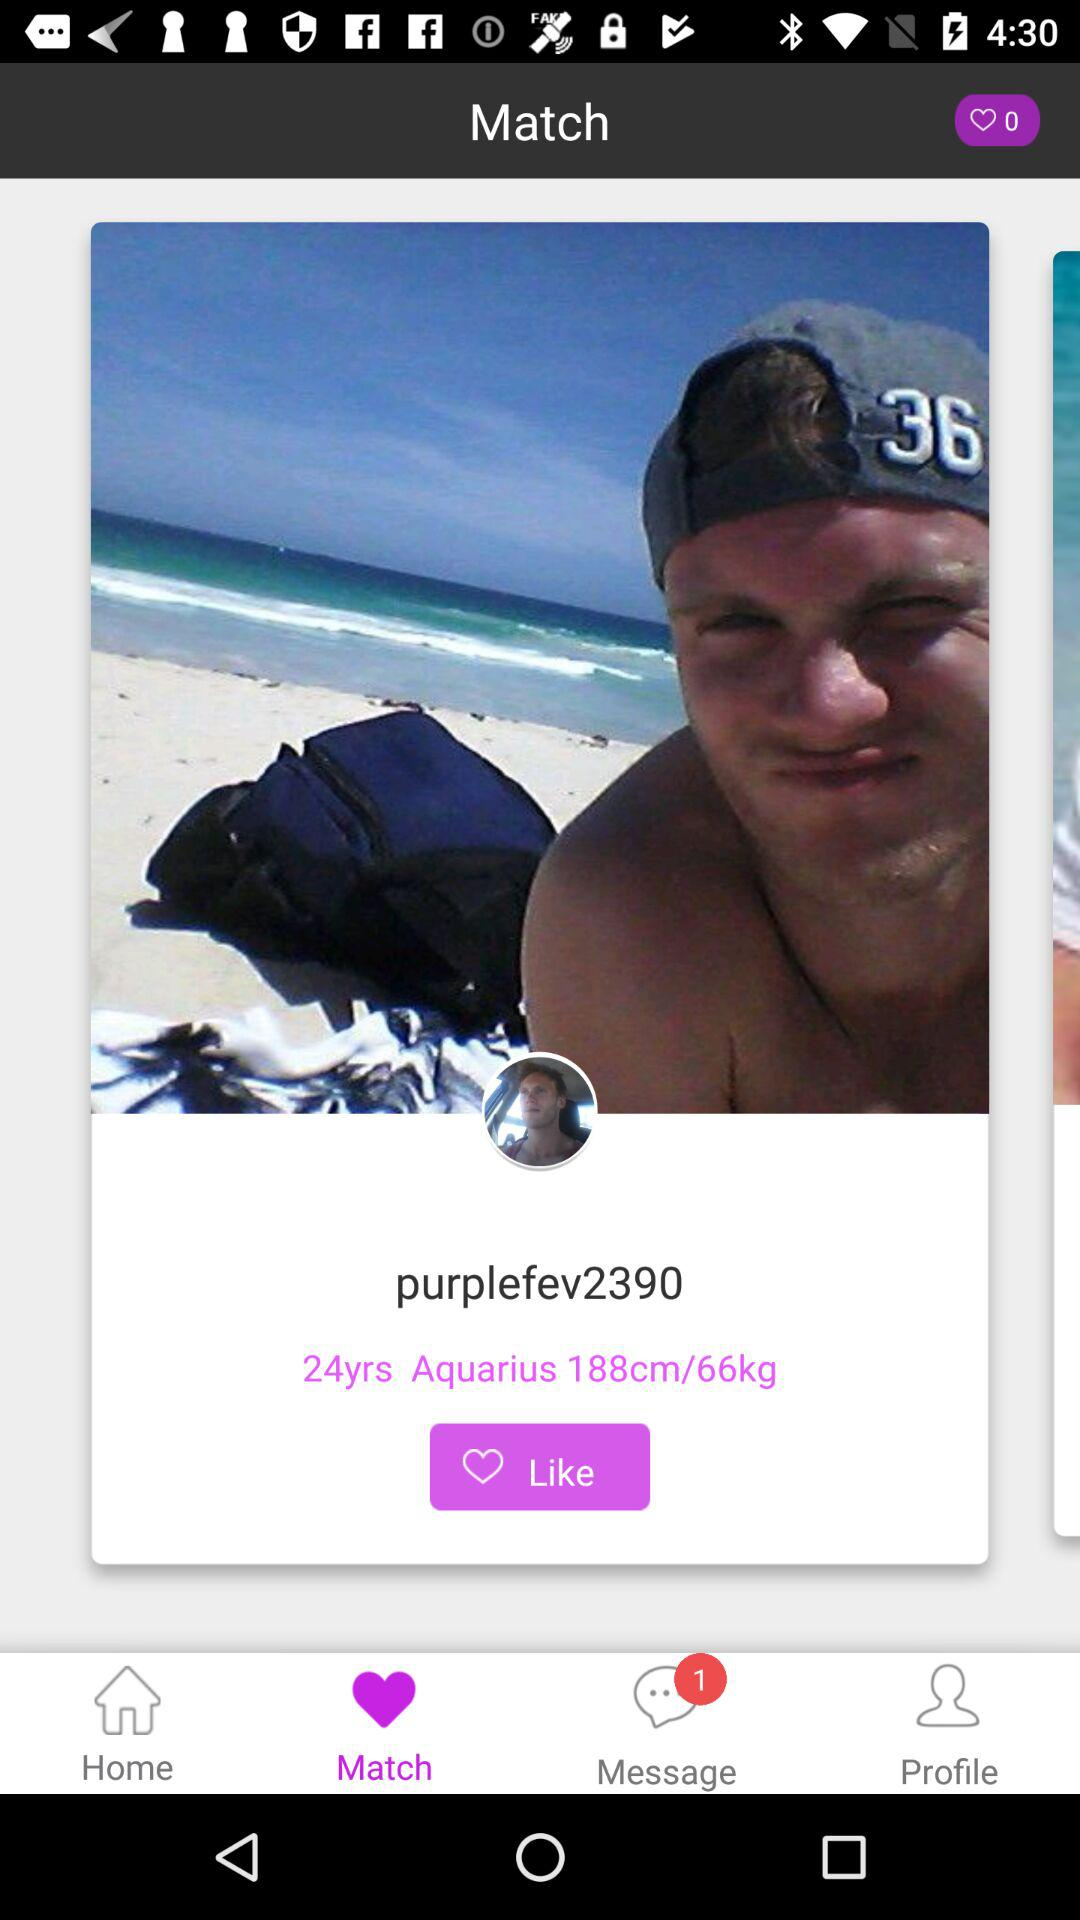What is the number of notifications on "Message"? The number of notification on message is 1. 